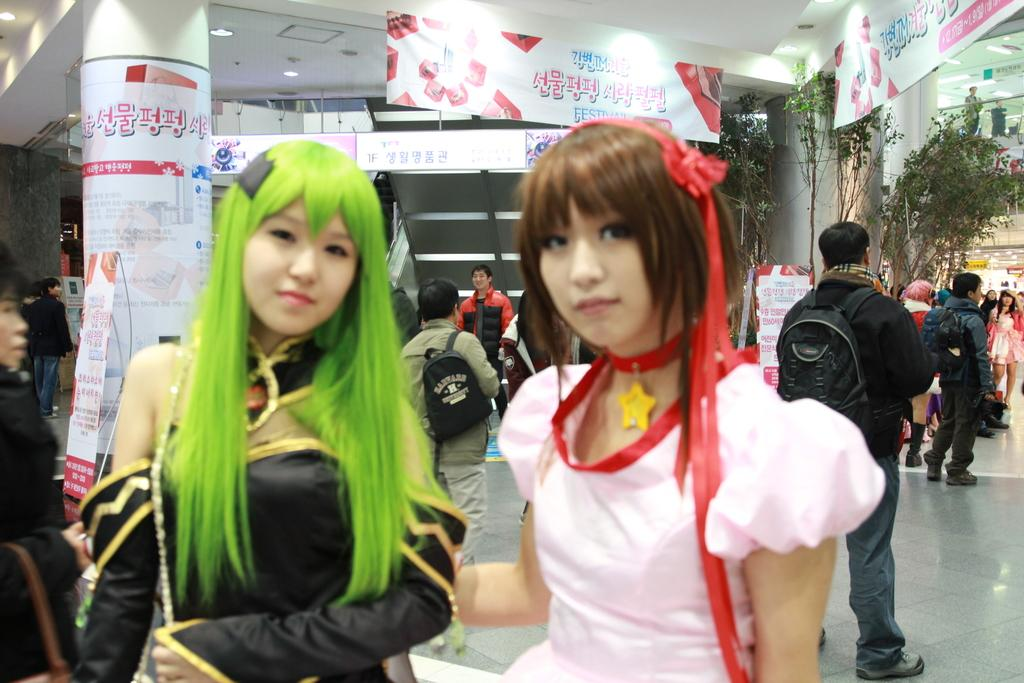How many women are in the image? There are two women standing in the image. Can you describe the other people in the image? There are other persons in the image, but their specific number is not mentioned. What can be seen hanging in the image? There are banners visible in the image. Where is the tree located in the image? The tree is in the right corner of the image. What type of wrench is being used by the women in the image? There is no wrench present in the image; the women are not using any tools. 